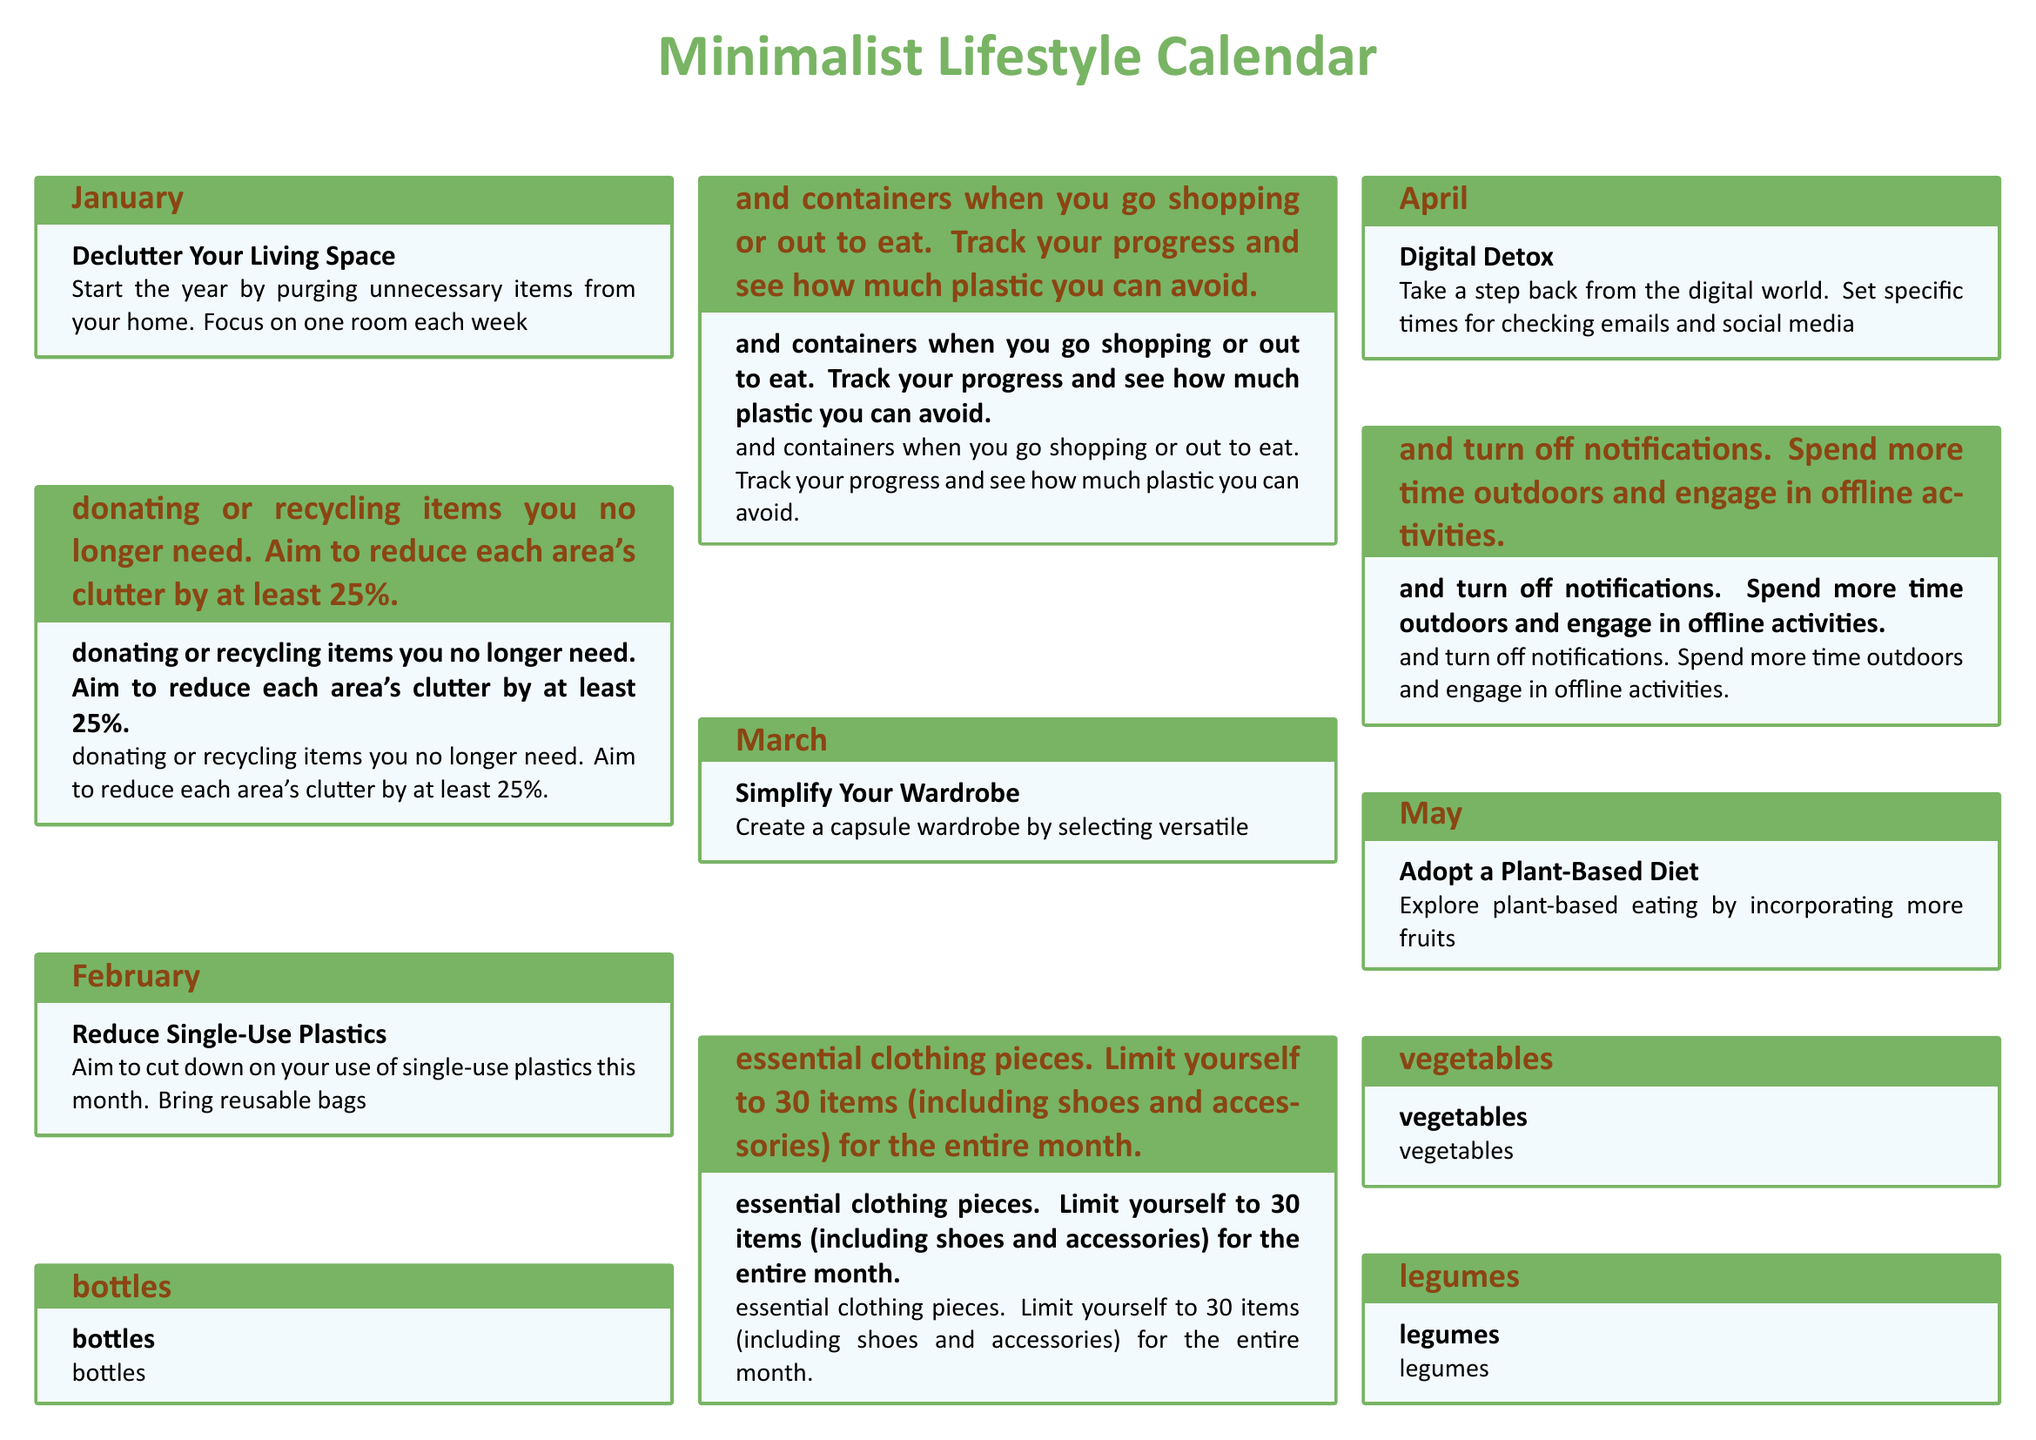What is the challenge for January? The challenge for January is about decluttering your living space by purging unnecessary items from your home.
Answer: Declutter Your Living Space How many items should you limit your wardrobe to in March? In March, the challenge is to limit your wardrobe to 30 items, including shoes and accessories.
Answer: 30 items What is the name of the challenge for September? The challenge for September focuses on aiming for a zero-waste month by practicing the 5 R's.
Answer: Waste-Free Challenge How many plant-based meals should you aim to prepare in May? In May, you should try to make at least 20 out of your 30 meals plant-based.
Answer: 20 Which month emphasizes eco-friendly transportation? The challenge in July specifically focuses on reducing carbon footprint through alternative transportation methods.
Answer: July What is the primary focus of November's challenge? November's challenge encourages planning for a minimalist holiday season, focusing on experiences over material gifts.
Answer: Minimalist Holiday Preparations During which month should you reflect on your achievements and plan for the next year? December is the month to reflect on achievements and plan for further simplification for the next year.
Answer: December What key action is recommended in April's challenge? The key action in April is to take a step back from the digital world and set limits on digital engagement.
Answer: Digital Detox What does the calendar suggest for community engagement in October? In October, the challenge suggests getting involved in local conservation efforts or community clean-up events.
Answer: Conscious Community Engagement 